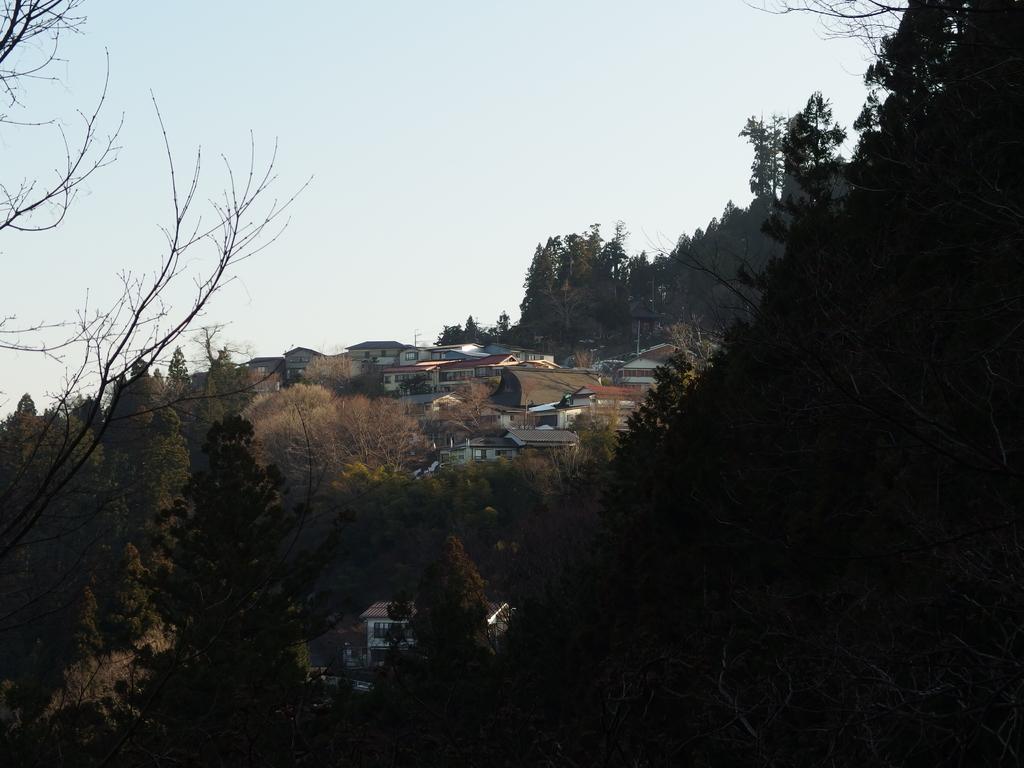In one or two sentences, can you explain what this image depicts? In this image I can see at the bottom there are trees, in the middle there are houses. At the top it is the sky. 